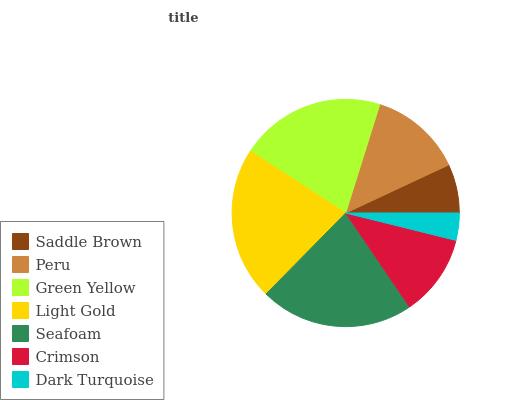Is Dark Turquoise the minimum?
Answer yes or no. Yes. Is Seafoam the maximum?
Answer yes or no. Yes. Is Peru the minimum?
Answer yes or no. No. Is Peru the maximum?
Answer yes or no. No. Is Peru greater than Saddle Brown?
Answer yes or no. Yes. Is Saddle Brown less than Peru?
Answer yes or no. Yes. Is Saddle Brown greater than Peru?
Answer yes or no. No. Is Peru less than Saddle Brown?
Answer yes or no. No. Is Peru the high median?
Answer yes or no. Yes. Is Peru the low median?
Answer yes or no. Yes. Is Seafoam the high median?
Answer yes or no. No. Is Dark Turquoise the low median?
Answer yes or no. No. 